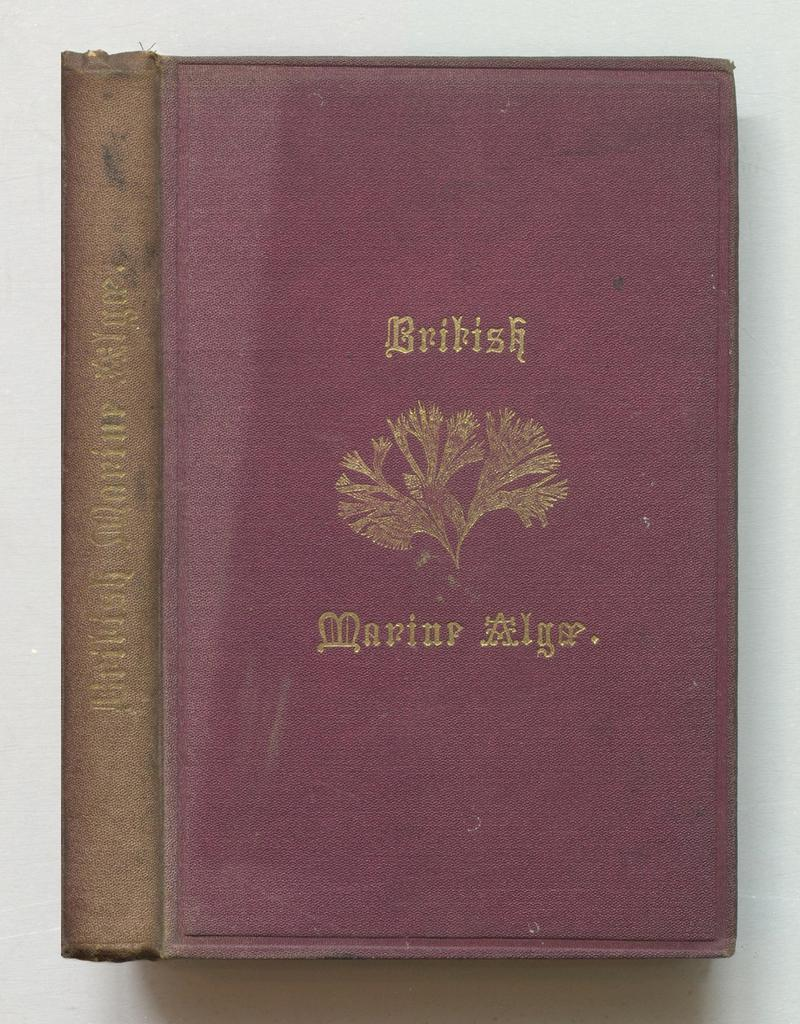<image>
Relay a brief, clear account of the picture shown. A purple and black book of British Marine Alge. on a table. 